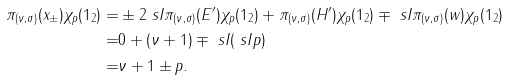<formula> <loc_0><loc_0><loc_500><loc_500>\pi _ { ( \nu , \sigma ) } ( x _ { \pm } ) \chi _ { p } ( 1 _ { 2 } ) = & \pm 2 \ s I \pi _ { ( \nu , \sigma ) } ( E ^ { \prime } ) \chi _ { p } ( 1 _ { 2 } ) + \pi _ { ( \nu , \sigma ) } ( H ^ { \prime } ) \chi _ { p } ( 1 _ { 2 } ) \mp \ s I \pi _ { ( \nu , \sigma ) } ( w ) \chi _ { p } ( 1 _ { 2 } ) \\ = & 0 + ( \nu + 1 ) \mp \ s I ( \ s I p ) \\ = & \nu + 1 \pm p .</formula> 